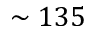<formula> <loc_0><loc_0><loc_500><loc_500>\sim 1 3 5</formula> 